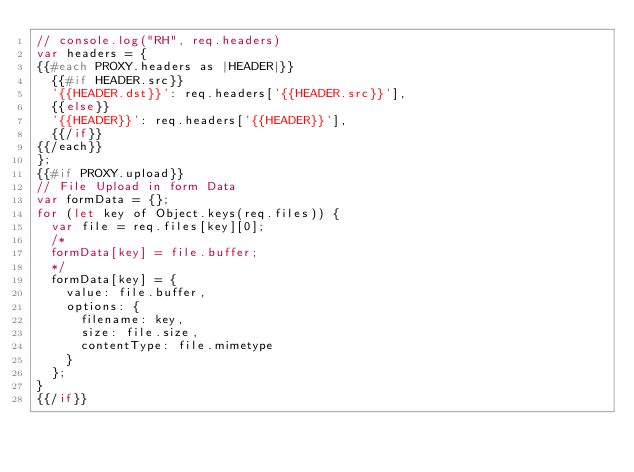<code> <loc_0><loc_0><loc_500><loc_500><_JavaScript_>// console.log("RH", req.headers)
var headers = {
{{#each PROXY.headers as |HEADER|}}
  {{#if HEADER.src}}
  '{{HEADER.dst}}': req.headers['{{HEADER.src}}'],
  {{else}}
  '{{HEADER}}': req.headers['{{HEADER}}'],
  {{/if}}
{{/each}}
};
{{#if PROXY.upload}}
// File Upload in form Data
var formData = {};
for (let key of Object.keys(req.files)) {
  var file = req.files[key][0];
  /*
  formData[key] = file.buffer;
  */
  formData[key] = {
    value: file.buffer,
    options: {
      filename: key,
      size: file.size,
      contentType: file.mimetype
    }
  };
}
{{/if}}
</code> 